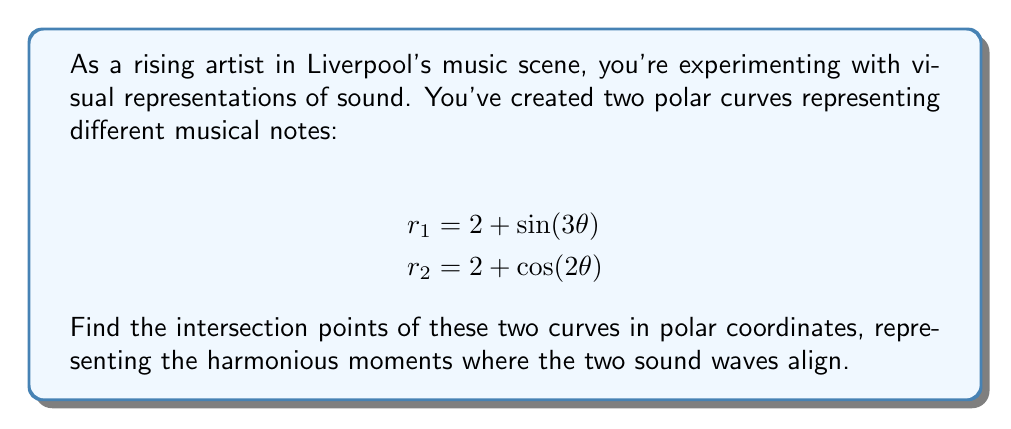Solve this math problem. To find the intersection points, we need to solve the equation:

$$2 + \sin(3\theta) = 2 + \cos(2\theta)$$

1) Simplify the equation:
   $$\sin(3\theta) = \cos(2\theta)$$

2) Use the trigonometric identity $\cos(2\theta) = \sin(\frac{\pi}{2} - 2\theta)$:
   $$\sin(3\theta) = \sin(\frac{\pi}{2} - 2\theta)$$

3) For this equation to be true, the arguments must be equal (or differ by multiples of $2\pi$):
   $$3\theta = \frac{\pi}{2} - 2\theta + 2\pi n$$, where $n$ is an integer

4) Solve for $\theta$:
   $$5\theta = \frac{\pi}{2} + 2\pi n$$
   $$\theta = \frac{\pi}{10} + \frac{2\pi n}{5}$$

5) The unique solutions in the interval $[0, 2\pi)$ are:
   $$\theta_1 = \frac{\pi}{10}, \theta_2 = \frac{5\pi}{10}, \theta_3 = \frac{9\pi}{10}, \theta_4 = \frac{13\pi}{10}, \theta_5 = \frac{17\pi}{10}$$

6) To find the $r$ values, substitute these $\theta$ values into either of the original equations. For example, using $r_1 = 2 + \sin(3\theta)$:

   $$r_1 = 2 + \sin(3 \cdot \frac{\pi}{10}) \approx 2.9511$$
   $$r_2 = 2 + \sin(3 \cdot \frac{5\pi}{10}) = 2$$
   $$r_3 = 2 + \sin(3 \cdot \frac{9\pi}{10}) \approx 1.0489$$
   $$r_4 = 2 + \sin(3 \cdot \frac{13\pi}{10}) \approx 1.0489$$
   $$r_5 = 2 + \sin(3 \cdot \frac{17\pi}{10}) \approx 2.9511$$
Answer: The intersection points in polar coordinates $(r, \theta)$ are:

$$(2.9511, \frac{\pi}{10}), (2, \frac{\pi}{2}), (1.0489, \frac{9\pi}{10}), (1.0489, \frac{13\pi}{10}), (2.9511, \frac{17\pi}{10})$$ 